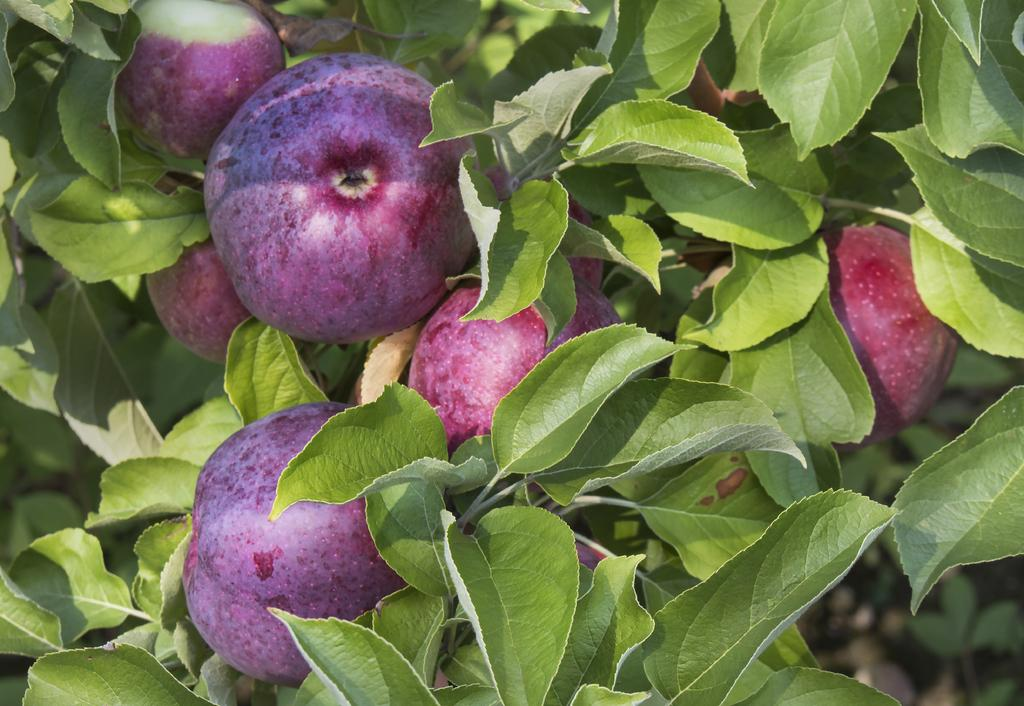What type of plant material can be seen in the image? There are leaves in the image. What else can be found in the image besides leaves? There are fruits in the image. What type of memory is stored in the bucket in the image? There is no bucket or memory present in the image; it only contains leaves and fruits. What type of wood can be seen in the image? There is no wood visible in the image; it only contains leaves and fruits. 